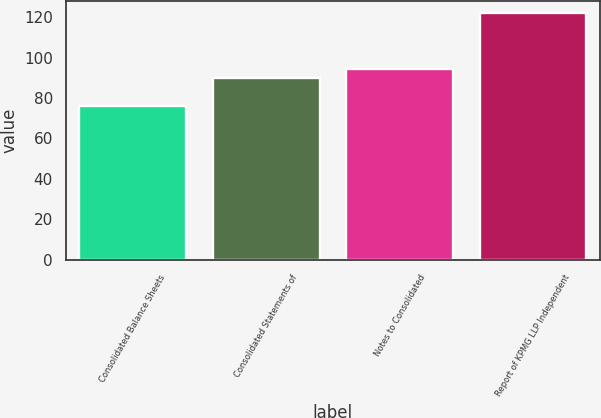Convert chart to OTSL. <chart><loc_0><loc_0><loc_500><loc_500><bar_chart><fcel>Consolidated Balance Sheets<fcel>Consolidated Statements of<fcel>Notes to Consolidated<fcel>Report of KPMG LLP Independent<nl><fcel>76<fcel>89.8<fcel>94.4<fcel>122<nl></chart> 